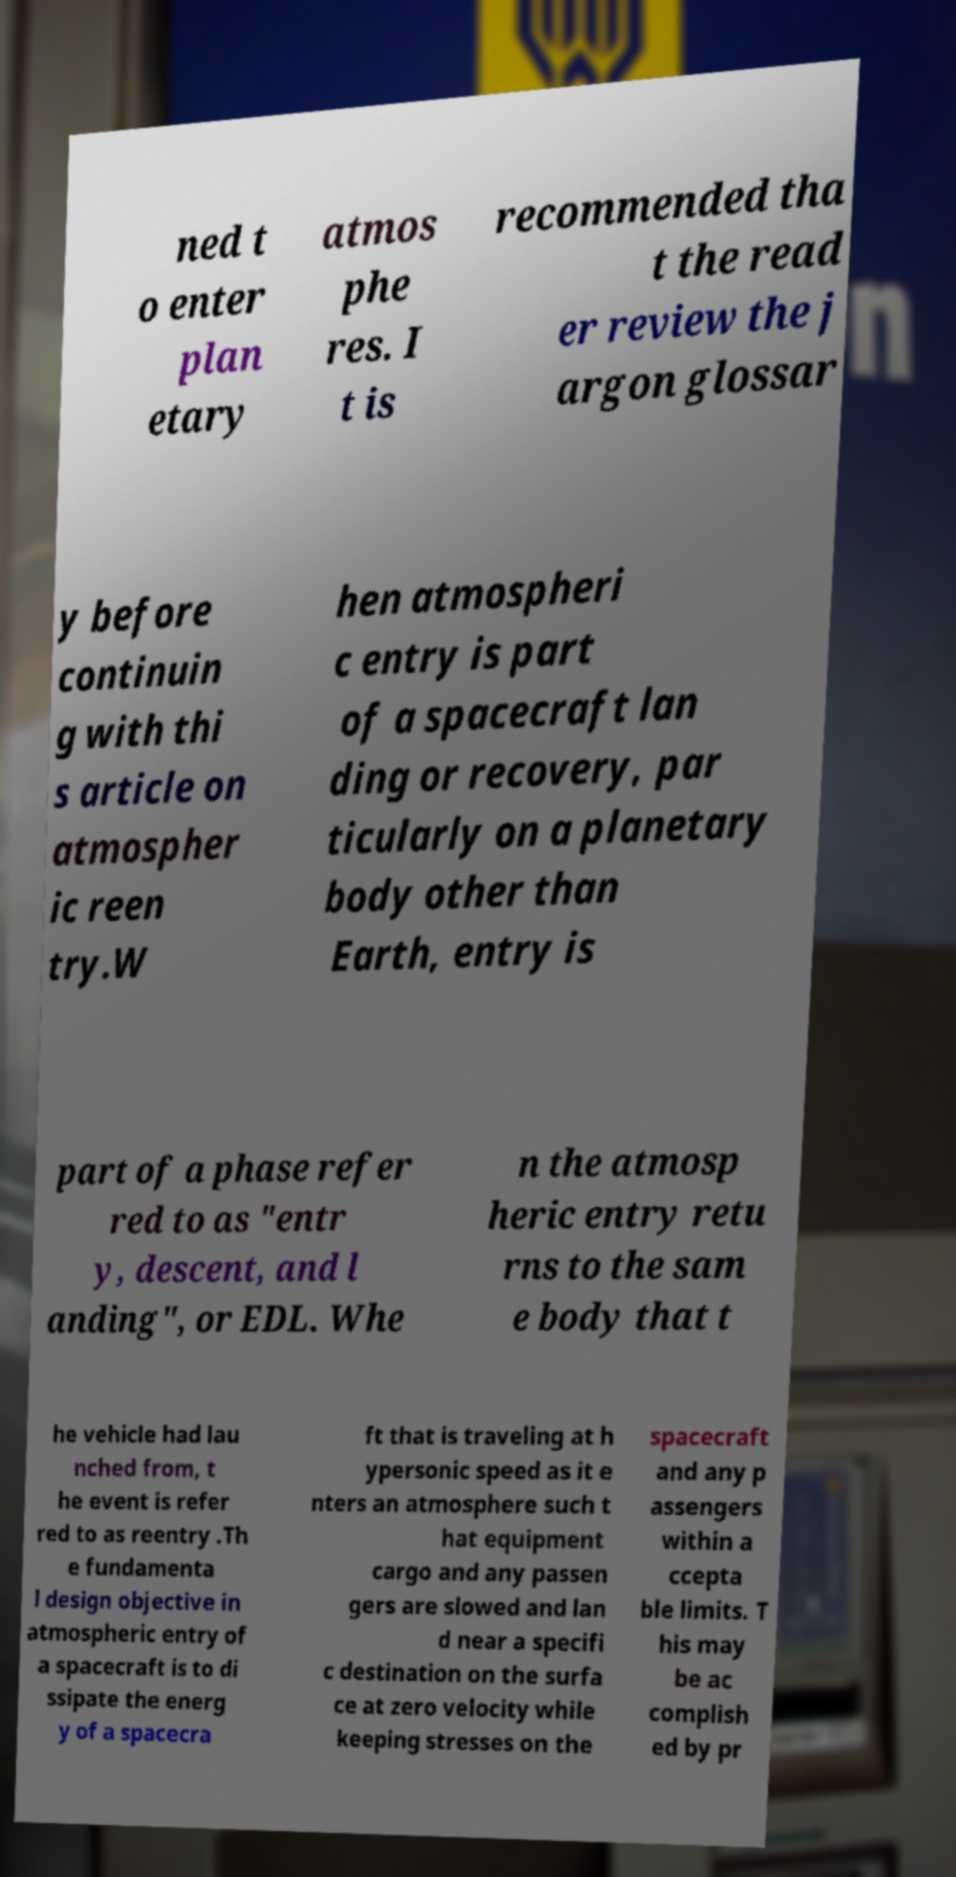Please read and relay the text visible in this image. What does it say? ned t o enter plan etary atmos phe res. I t is recommended tha t the read er review the j argon glossar y before continuin g with thi s article on atmospher ic reen try.W hen atmospheri c entry is part of a spacecraft lan ding or recovery, par ticularly on a planetary body other than Earth, entry is part of a phase refer red to as "entr y, descent, and l anding", or EDL. Whe n the atmosp heric entry retu rns to the sam e body that t he vehicle had lau nched from, t he event is refer red to as reentry .Th e fundamenta l design objective in atmospheric entry of a spacecraft is to di ssipate the energ y of a spacecra ft that is traveling at h ypersonic speed as it e nters an atmosphere such t hat equipment cargo and any passen gers are slowed and lan d near a specifi c destination on the surfa ce at zero velocity while keeping stresses on the spacecraft and any p assengers within a ccepta ble limits. T his may be ac complish ed by pr 